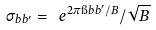Convert formula to latex. <formula><loc_0><loc_0><loc_500><loc_500>\sigma _ { b b ^ { \prime } } = \ e ^ { 2 \pi \i b b ^ { \prime } / B } / \sqrt { B }</formula> 